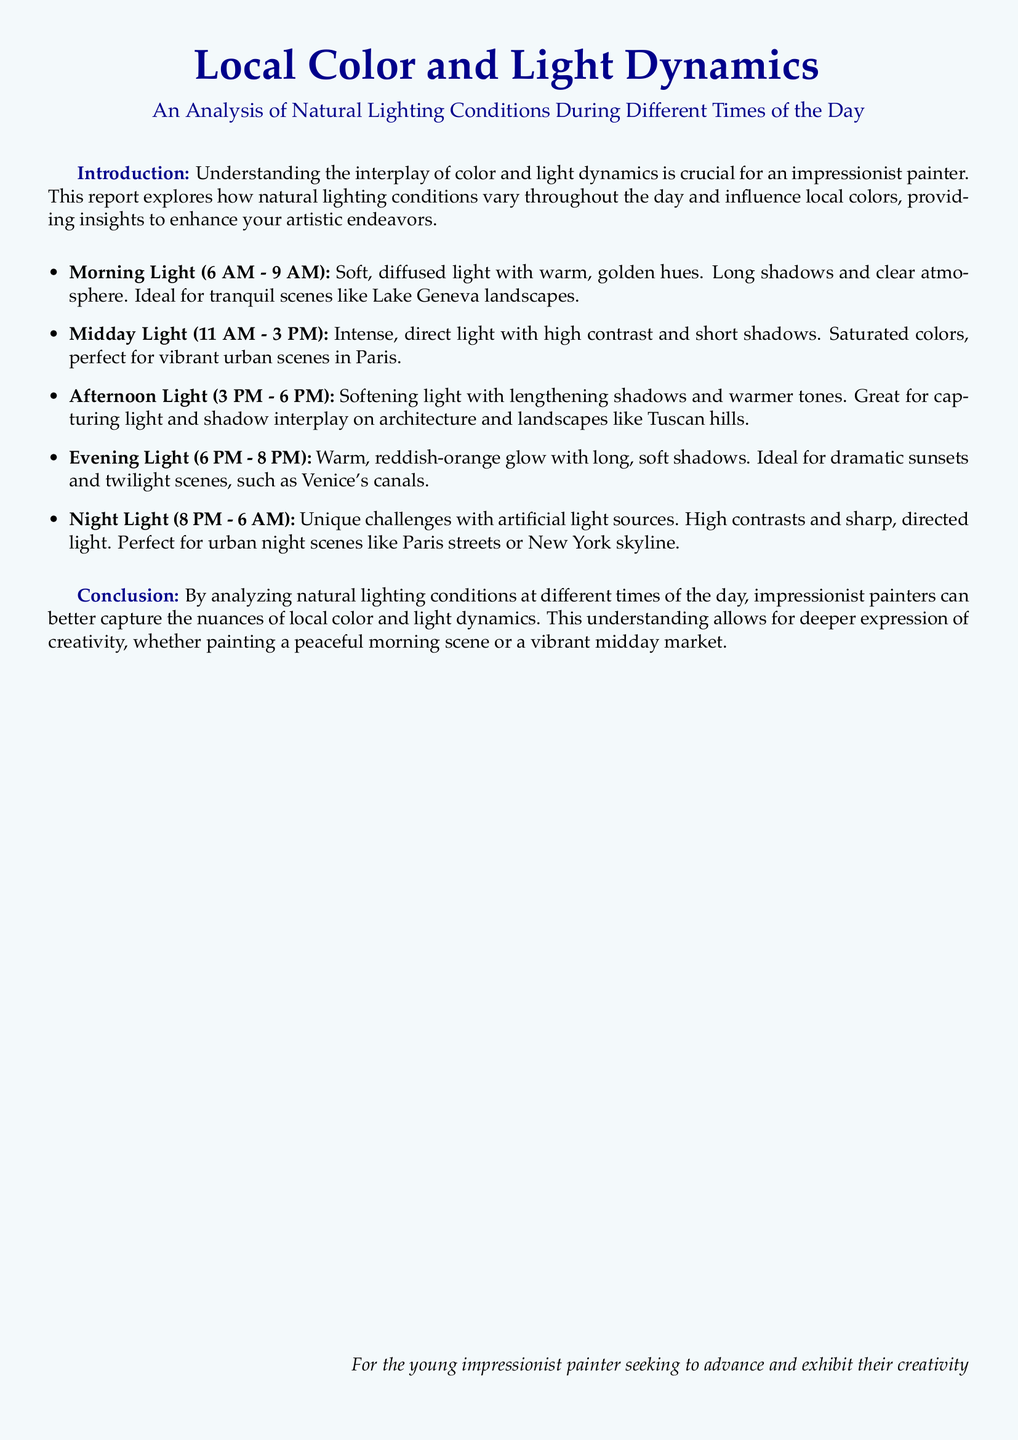What is the title of the document? The title of the document is prominently displayed at the beginning, which is "Local Color and Light Dynamics."
Answer: Local Color and Light Dynamics What time range is considered for Morning Light? The Morning Light section specifies the time range as 6 AM to 9 AM.
Answer: 6 AM - 9 AM What type of scenes is Midday Light ideal for? According to the document, Midday Light is perfect for vibrant urban scenes in Paris.
Answer: vibrant urban scenes in Paris Which two colors describe the Evening Light? The document describes the Evening Light as a warm reddish-orange glow.
Answer: reddish-orange What is the main challenge of Night Light? The Night Light section mentions that the main challenge comes from artificial light sources.
Answer: artificial light sources How does Afternoon Light affect shadows? The document states that Afternoon Light results in lengthening shadows.
Answer: lengthening shadows What artistic advantage does analyzing natural lighting provide? The conclusion suggests that understanding natural lighting allows for deeper expression of creativity.
Answer: deeper expression of creativity What type of document is this? The document characteristics reveal that it is an analysis of natural lighting conditions aimed at painters.
Answer: analysis of natural lighting conditions 